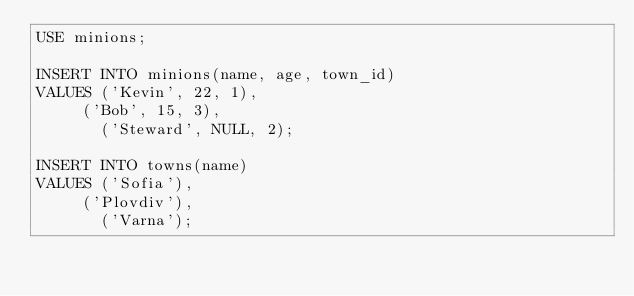Convert code to text. <code><loc_0><loc_0><loc_500><loc_500><_SQL_>USE minions;

INSERT INTO minions(name, age, town_id) 
VALUES ('Kevin', 22, 1),
	   ('Bob', 15, 3),
       ('Steward', NULL, 2);
       
INSERT INTO towns(name) 
VALUES ('Sofia'),
	   ('Plovdiv'),
       ('Varna');</code> 